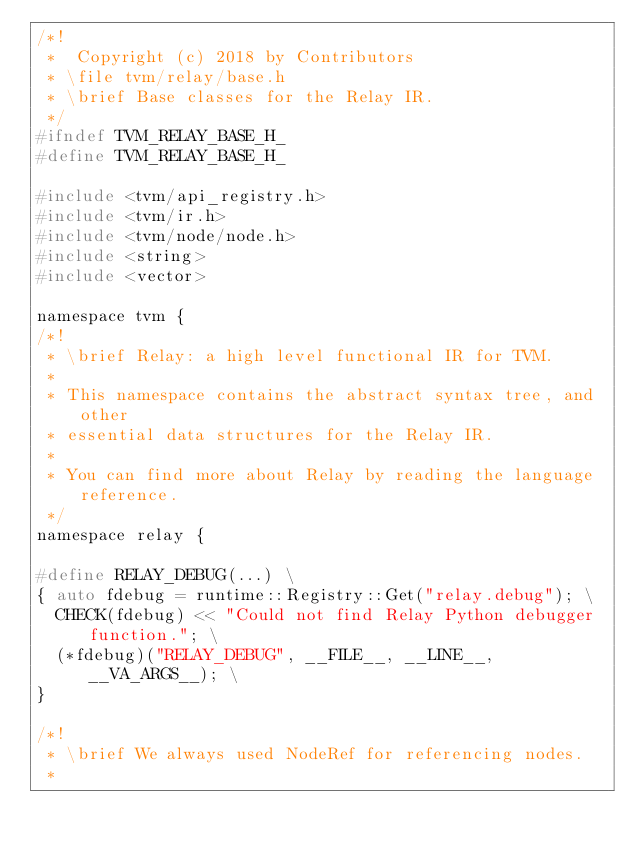<code> <loc_0><loc_0><loc_500><loc_500><_C_>/*!
 *  Copyright (c) 2018 by Contributors
 * \file tvm/relay/base.h
 * \brief Base classes for the Relay IR.
 */
#ifndef TVM_RELAY_BASE_H_
#define TVM_RELAY_BASE_H_

#include <tvm/api_registry.h>
#include <tvm/ir.h>
#include <tvm/node/node.h>
#include <string>
#include <vector>

namespace tvm {
/*!
 * \brief Relay: a high level functional IR for TVM.
 *
 * This namespace contains the abstract syntax tree, and other
 * essential data structures for the Relay IR.
 *
 * You can find more about Relay by reading the language reference.
 */
namespace relay {

#define RELAY_DEBUG(...) \
{ auto fdebug = runtime::Registry::Get("relay.debug"); \
  CHECK(fdebug) << "Could not find Relay Python debugger function."; \
  (*fdebug)("RELAY_DEBUG", __FILE__, __LINE__, __VA_ARGS__); \
}

/*!
 * \brief We always used NodeRef for referencing nodes.
 *</code> 